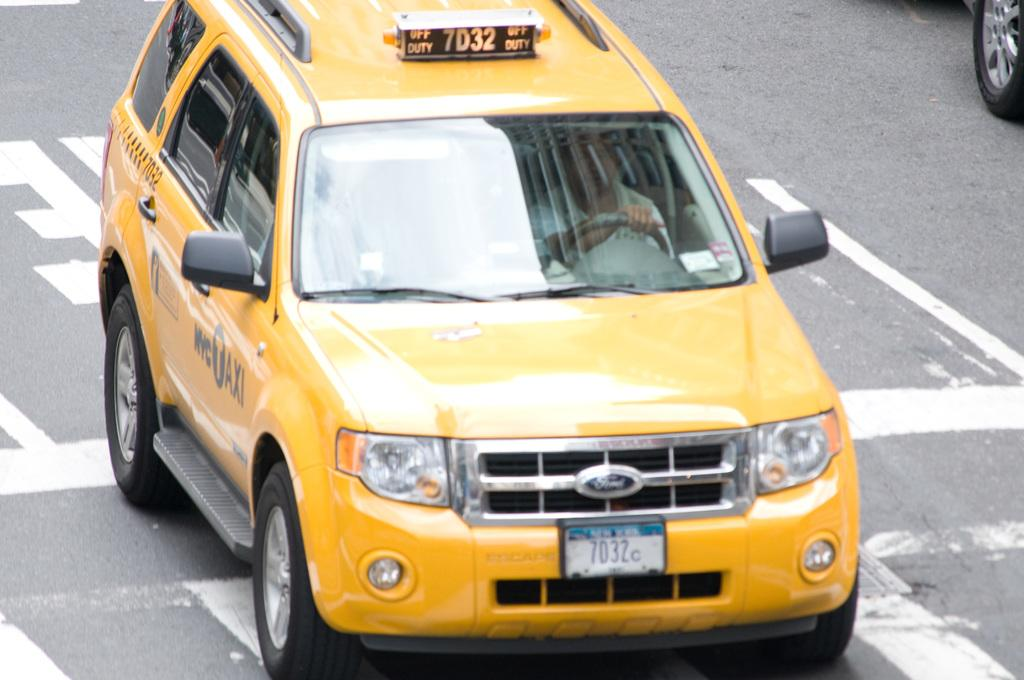<image>
Create a compact narrative representing the image presented. a car that has 7032 at the top of it 